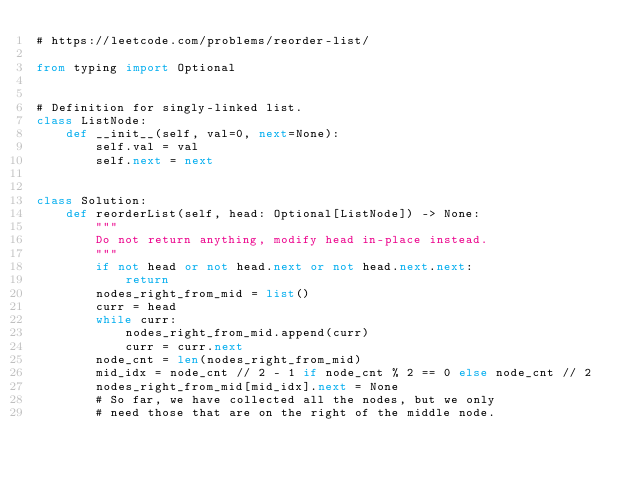<code> <loc_0><loc_0><loc_500><loc_500><_Python_># https://leetcode.com/problems/reorder-list/

from typing import Optional


# Definition for singly-linked list.
class ListNode:
    def __init__(self, val=0, next=None):
        self.val = val
        self.next = next


class Solution:
    def reorderList(self, head: Optional[ListNode]) -> None:
        """
        Do not return anything, modify head in-place instead.
        """
        if not head or not head.next or not head.next.next:
            return
        nodes_right_from_mid = list()
        curr = head
        while curr:
            nodes_right_from_mid.append(curr)
            curr = curr.next
        node_cnt = len(nodes_right_from_mid)
        mid_idx = node_cnt // 2 - 1 if node_cnt % 2 == 0 else node_cnt // 2
        nodes_right_from_mid[mid_idx].next = None
        # So far, we have collected all the nodes, but we only
        # need those that are on the right of the middle node.</code> 